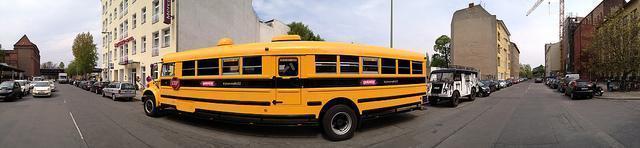What is this yellow bus doing?
Pick the correct solution from the four options below to address the question.
Options: Turning left, reversing, turning right, parking. Turning right. 